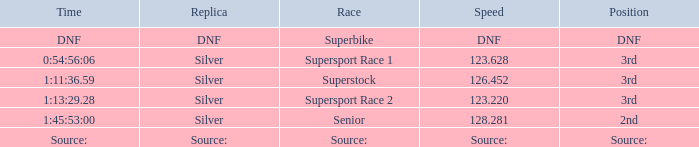Which position has a speed of 123.220? 3rd. Can you give me this table as a dict? {'header': ['Time', 'Replica', 'Race', 'Speed', 'Position'], 'rows': [['DNF', 'DNF', 'Superbike', 'DNF', 'DNF'], ['0:54:56:06', 'Silver', 'Supersport Race 1', '123.628', '3rd'], ['1:11:36.59', 'Silver', 'Superstock', '126.452', '3rd'], ['1:13:29.28', 'Silver', 'Supersport Race 2', '123.220', '3rd'], ['1:45:53:00', 'Silver', 'Senior', '128.281', '2nd'], ['Source:', 'Source:', 'Source:', 'Source:', 'Source:']]} 